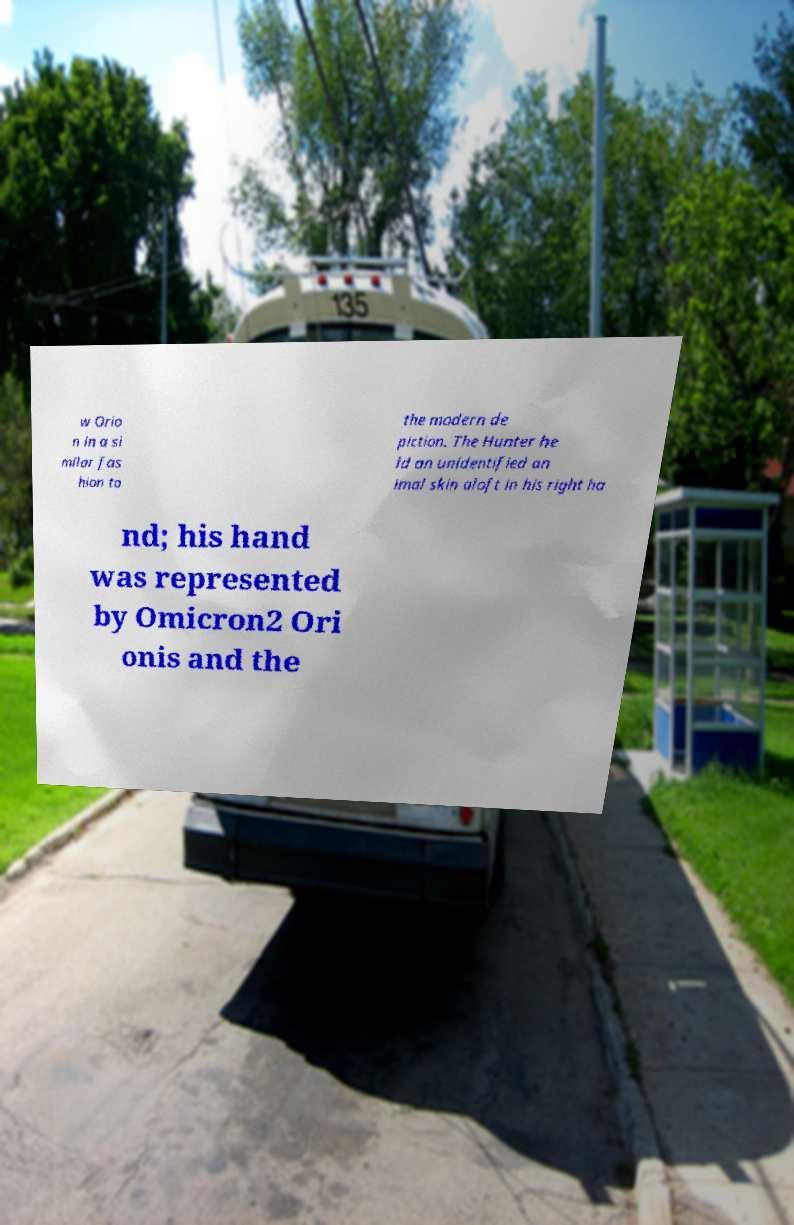Could you extract and type out the text from this image? w Orio n in a si milar fas hion to the modern de piction. The Hunter he ld an unidentified an imal skin aloft in his right ha nd; his hand was represented by Omicron2 Ori onis and the 